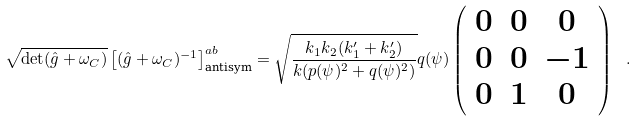<formula> <loc_0><loc_0><loc_500><loc_500>\sqrt { \det ( \hat { g } + \omega _ { C } ) } \left [ ( \hat { g } + \omega _ { C } ) ^ { - 1 } \right ] _ { \text {antisym} } ^ { a b } = \sqrt { \frac { k _ { 1 } k _ { 2 } ( k _ { 1 } ^ { \prime } + k _ { 2 } ^ { \prime } ) } { k ( p ( \psi ) ^ { 2 } + q ( \psi ) ^ { 2 } ) } } q ( \psi ) \left ( \begin{array} { c c c } 0 & 0 & 0 \\ 0 & 0 & - 1 \\ 0 & 1 & 0 \end{array} \right ) \ .</formula> 